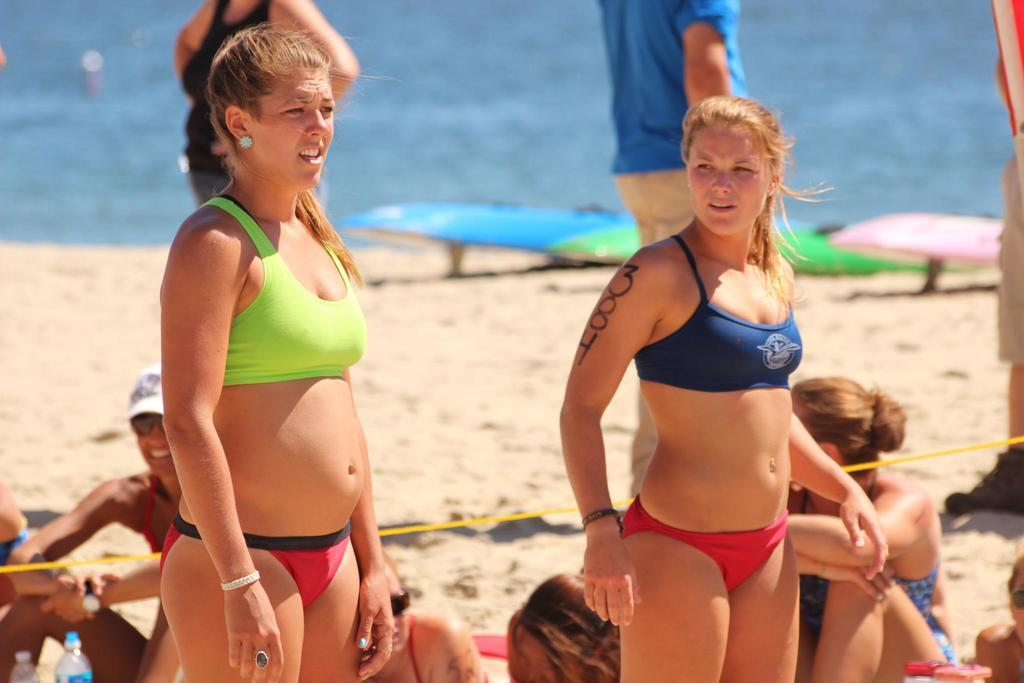Who or what is present in the image? There are people in the image. What type of surface can be seen in the image? There is sand visible in the image. What can be used for drinking or storage in the image? There are bottles in the image. Can you describe any other objects in the image? There are other objects in the image, but their specific details are not mentioned in the provided facts. What can be seen in the distance in the image? There is water visible in the background of the image. How does the effect of the watch influence the tomatoes in the image? There is no watch or tomatoes present in the image, so it is not possible to determine any influence or effect. 